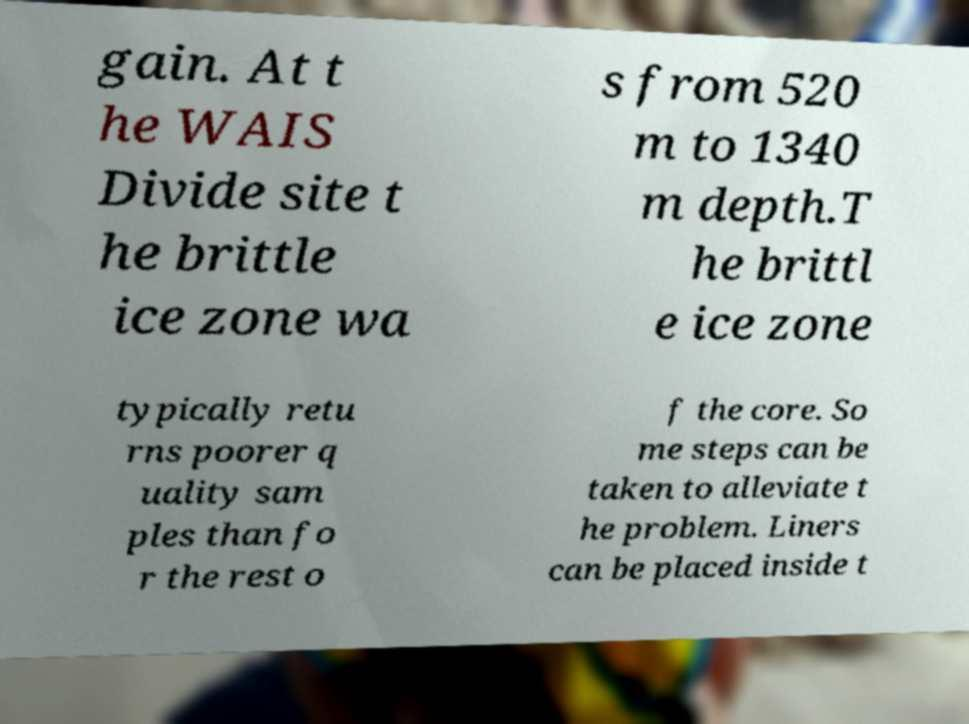Please identify and transcribe the text found in this image. gain. At t he WAIS Divide site t he brittle ice zone wa s from 520 m to 1340 m depth.T he brittl e ice zone typically retu rns poorer q uality sam ples than fo r the rest o f the core. So me steps can be taken to alleviate t he problem. Liners can be placed inside t 